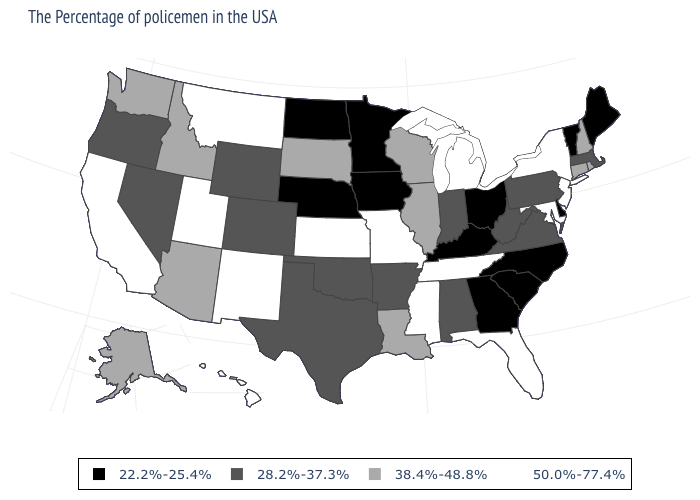Among the states that border Nevada , does California have the highest value?
Short answer required. Yes. What is the value of Colorado?
Write a very short answer. 28.2%-37.3%. Which states have the lowest value in the USA?
Answer briefly. Maine, Vermont, Delaware, North Carolina, South Carolina, Ohio, Georgia, Kentucky, Minnesota, Iowa, Nebraska, North Dakota. What is the value of Oregon?
Be succinct. 28.2%-37.3%. Name the states that have a value in the range 50.0%-77.4%?
Give a very brief answer. New York, New Jersey, Maryland, Florida, Michigan, Tennessee, Mississippi, Missouri, Kansas, New Mexico, Utah, Montana, California, Hawaii. Does Nevada have the same value as Wyoming?
Short answer required. Yes. What is the highest value in the USA?
Quick response, please. 50.0%-77.4%. Which states hav the highest value in the Northeast?
Keep it brief. New York, New Jersey. What is the value of Arizona?
Be succinct. 38.4%-48.8%. Name the states that have a value in the range 22.2%-25.4%?
Give a very brief answer. Maine, Vermont, Delaware, North Carolina, South Carolina, Ohio, Georgia, Kentucky, Minnesota, Iowa, Nebraska, North Dakota. Name the states that have a value in the range 22.2%-25.4%?
Answer briefly. Maine, Vermont, Delaware, North Carolina, South Carolina, Ohio, Georgia, Kentucky, Minnesota, Iowa, Nebraska, North Dakota. Does Wyoming have the lowest value in the West?
Give a very brief answer. Yes. What is the value of North Carolina?
Give a very brief answer. 22.2%-25.4%. Name the states that have a value in the range 38.4%-48.8%?
Concise answer only. Rhode Island, New Hampshire, Connecticut, Wisconsin, Illinois, Louisiana, South Dakota, Arizona, Idaho, Washington, Alaska. Does Vermont have the lowest value in the Northeast?
Give a very brief answer. Yes. 